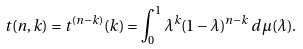<formula> <loc_0><loc_0><loc_500><loc_500>t ( n , k ) = t ^ { ( n - k ) } ( k ) = \int _ { 0 } ^ { 1 } \lambda ^ { k } ( 1 - \lambda ) ^ { n - k } \, d \mu ( \lambda ) .</formula> 